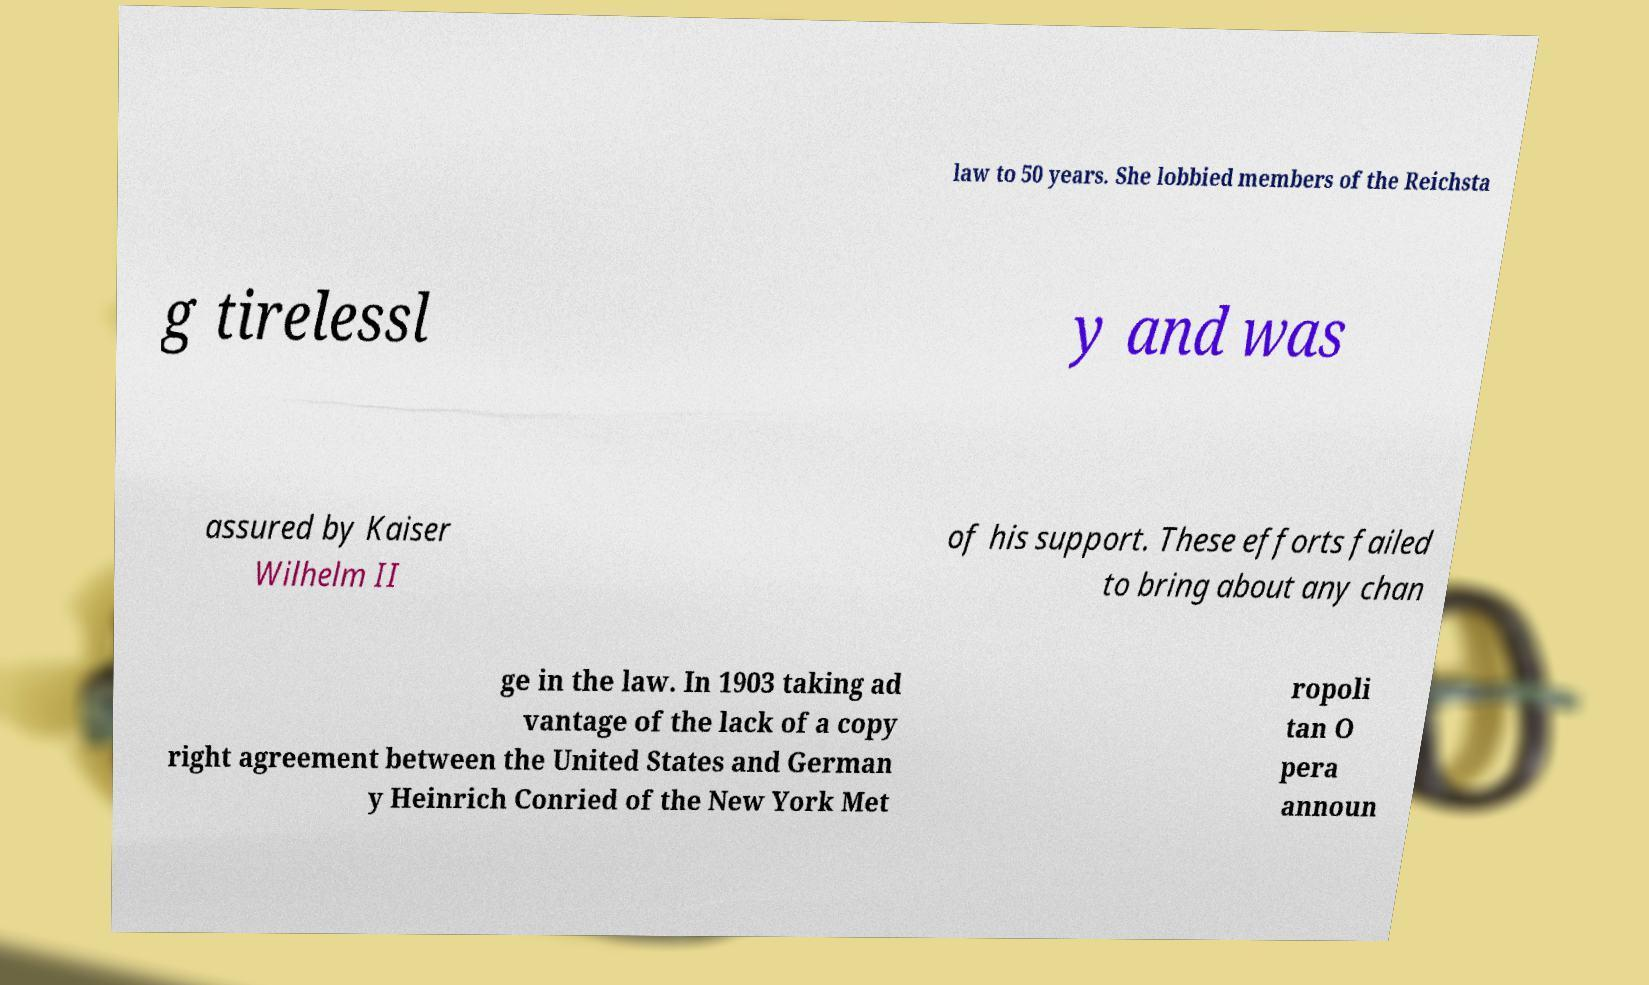I need the written content from this picture converted into text. Can you do that? law to 50 years. She lobbied members of the Reichsta g tirelessl y and was assured by Kaiser Wilhelm II of his support. These efforts failed to bring about any chan ge in the law. In 1903 taking ad vantage of the lack of a copy right agreement between the United States and German y Heinrich Conried of the New York Met ropoli tan O pera announ 